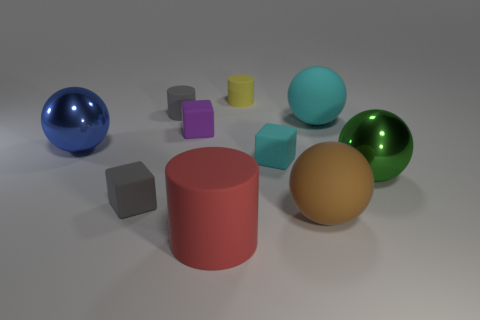Subtract all big green balls. How many balls are left? 3 Subtract 1 cylinders. How many cylinders are left? 2 Subtract all shiny things. Subtract all gray cylinders. How many objects are left? 7 Add 1 rubber cylinders. How many rubber cylinders are left? 4 Add 10 blue shiny cylinders. How many blue shiny cylinders exist? 10 Subtract all cyan cubes. How many cubes are left? 2 Subtract 1 cyan blocks. How many objects are left? 9 Subtract all spheres. How many objects are left? 6 Subtract all red balls. Subtract all purple cylinders. How many balls are left? 4 Subtract all cyan balls. How many purple cylinders are left? 0 